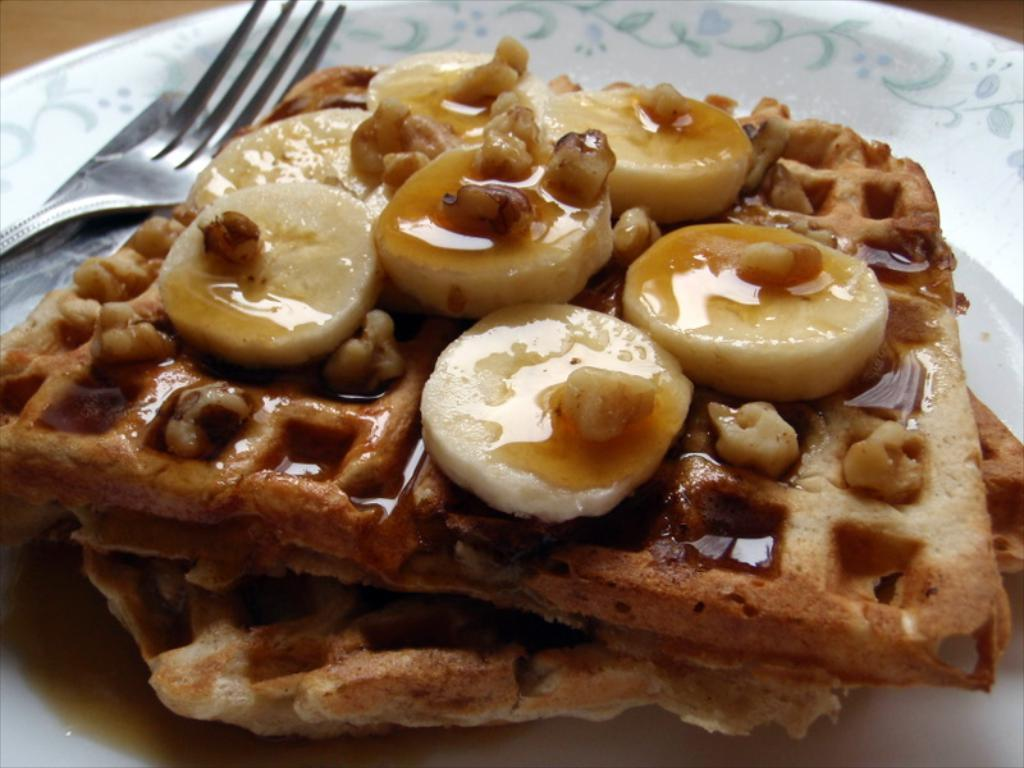What color is the plate that is visible in the image? The plate is white. What utensils are present on the plate in the image? A knife and a fork are present on the plate. What types of food can be seen on the plate? There are different types of food on the plate. How many pigs are visible on the plate in the image? There are no pigs present on the plate in the image. What type of ghost can be seen interacting with the food on the plate? There is no ghost present in the image; it features a plate with food, a knife, and a fork. 